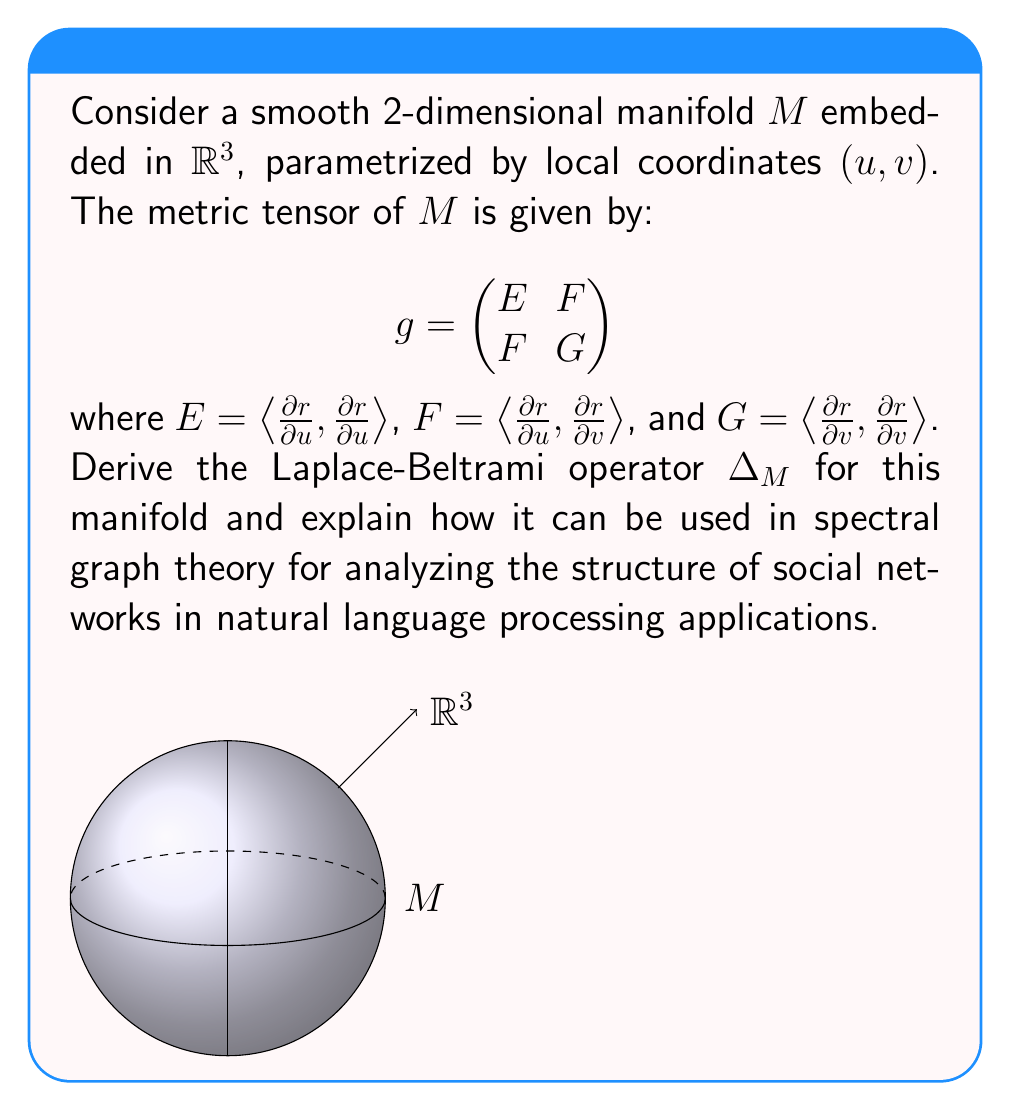Teach me how to tackle this problem. To derive the Laplace-Beltrami operator for the given manifold, we'll follow these steps:

1) The Laplace-Beltrami operator is defined as:

   $$\Delta_M f = \frac{1}{\sqrt{|g|}} \sum_{i,j=1}^2 \frac{\partial}{\partial x^i} \left(\sqrt{|g|} g^{ij} \frac{\partial f}{\partial x^j}\right)$$

   where $|g|$ is the determinant of the metric tensor, and $g^{ij}$ are the components of the inverse metric tensor.

2) For our 2D manifold, we have:

   $$|g| = EG - F^2$$
   $$g^{-1} = \frac{1}{EG-F^2} \begin{pmatrix}
   G & -F \\
   -F & E
   \end{pmatrix}$$

3) Expanding the Laplace-Beltrami operator:

   $$\Delta_M f = \frac{1}{\sqrt{EG-F^2}} \left[\frac{\partial}{\partial u} \left(\frac{\sqrt{EG-F^2}}{EG-F^2} \left(G\frac{\partial f}{\partial u} - F\frac{\partial f}{\partial v}\right)\right) + \frac{\partial}{\partial v} \left(\frac{\sqrt{EG-F^2}}{EG-F^2} \left(-F\frac{\partial f}{\partial u} + E\frac{\partial f}{\partial v}\right)\right)\right]$$

4) This is the Laplace-Beltrami operator for our 2D manifold.

Application in spectral graph theory for NLP:

1) In spectral graph theory, we can represent a social network as a graph where nodes are users and edges represent connections.

2) The graph Laplacian is an analog of the Laplace-Beltrami operator for discrete structures. For a graph $G$ with adjacency matrix $A$ and degree matrix $D$, the graph Laplacian is $L = D - A$.

3) The eigenvectors of $L$ provide information about the graph's structure, including communities and clusters.

4) In NLP applications, we can use this to:
   - Detect communities in social networks based on language use
   - Analyze the spread of information or memes in the network
   - Perform dimensionality reduction for visualizing high-dimensional NLP data

5) The continuous analog (Laplace-Beltrami operator) can be used when working with continuous representations of discrete data, such as word embeddings or sentence embeddings in a high-dimensional space.

6) By analyzing the spectral properties of the Laplace-Beltrami operator on the manifold of embeddings, we can gain insights into the structure and relationships in the language data, which can inform NLP tasks such as text classification, sentiment analysis, or language generation.
Answer: $$\Delta_M f = \frac{1}{\sqrt{EG-F^2}} \left[\frac{\partial}{\partial u} \left(\frac{\sqrt{EG-F^2}}{EG-F^2} \left(G\frac{\partial f}{\partial u} - F\frac{\partial f}{\partial v}\right)\right) + \frac{\partial}{\partial v} \left(\frac{\sqrt{EG-F^2}}{EG-F^2} \left(-F\frac{\partial f}{\partial u} + E\frac{\partial f}{\partial v}\right)\right)\right]$$ 